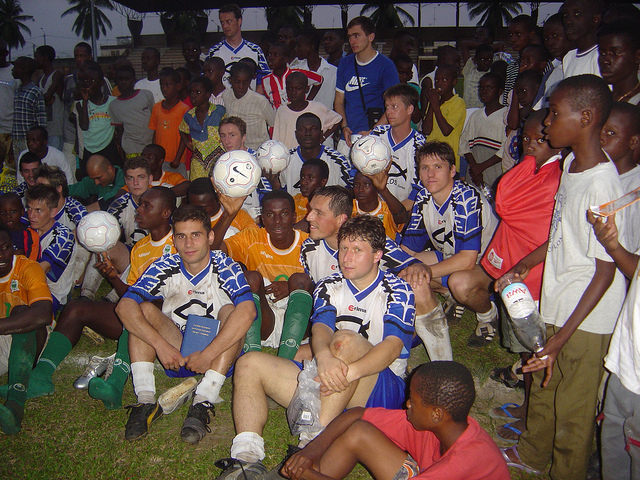<image>How many feet are in the picture? I don't know the exact number of feet in the picture. It could be anywhere from 6 to 13. How many feet are in the picture? I don't know how many feet are in the picture. It can be seen 10, 11, 12 or 13 feet. 